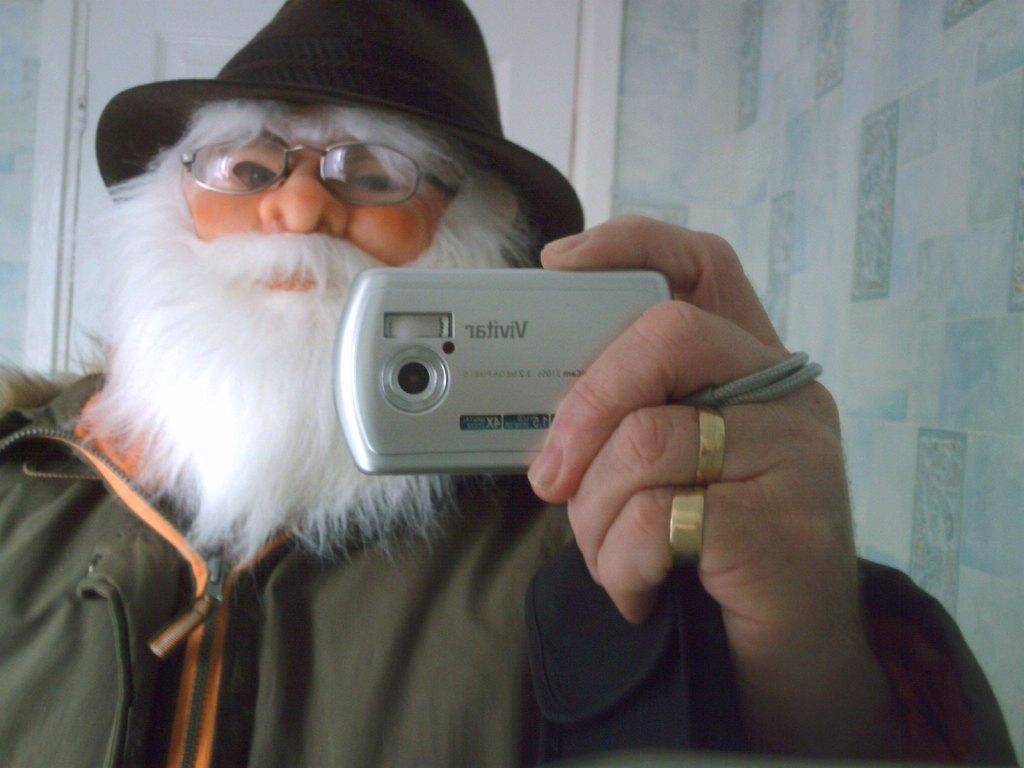What is the main subject of the image? The main subject of the image is a man. What is the man holding in his hand? The man is holding a camera in his hand. Can you describe the man's attire? The man is wearing a hat, a mask, spectacles, and a green-colored coat. What is the condition of the edge of the man's coat in the image? There is no information provided about the condition of the edge of the man's coat in the image. Is the man sleeping in the image? No, the man is not sleeping in the image; he is holding a camera and wearing various items of clothing. 